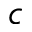Convert formula to latex. <formula><loc_0><loc_0><loc_500><loc_500>c</formula> 